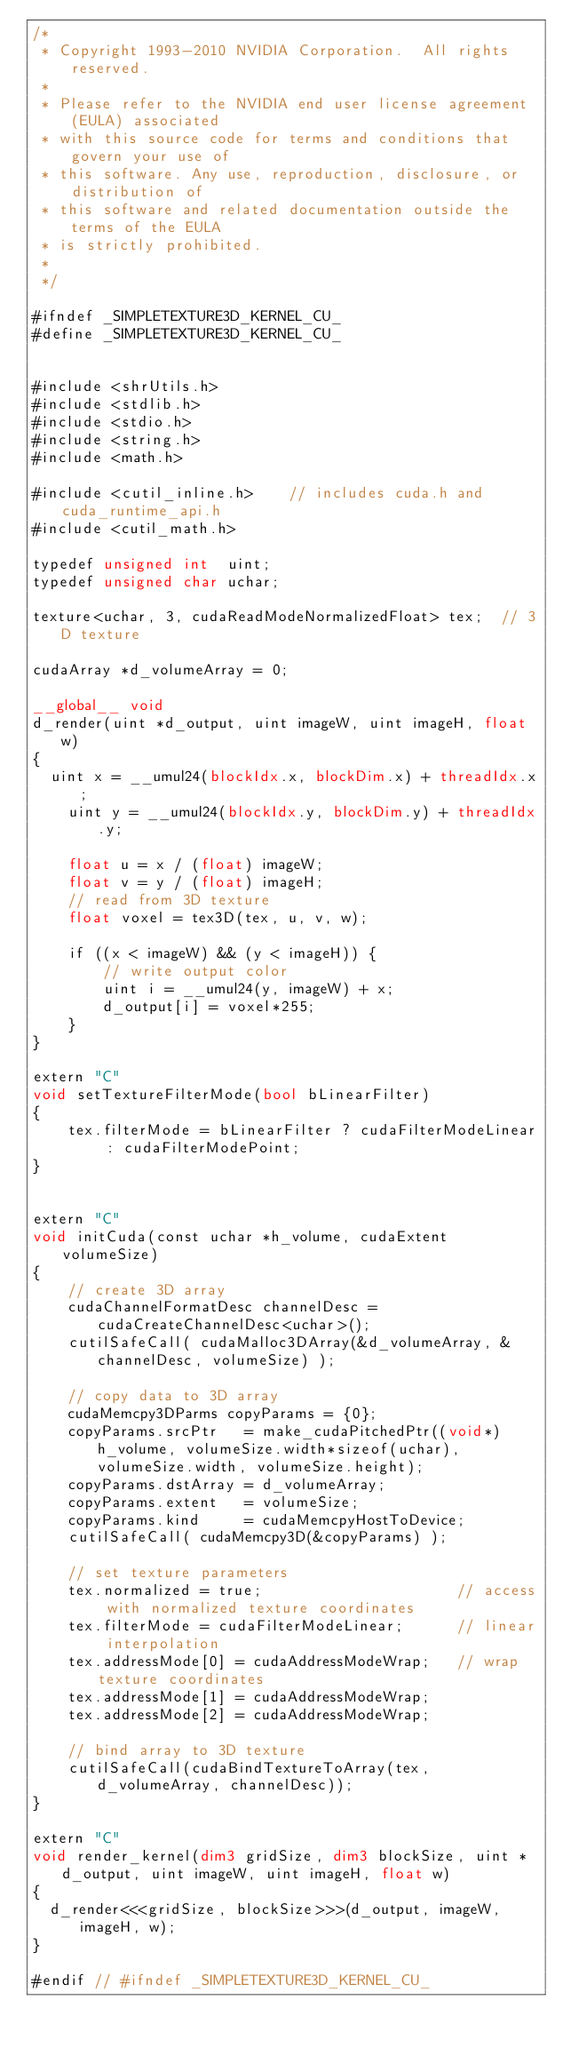Convert code to text. <code><loc_0><loc_0><loc_500><loc_500><_Cuda_>/*
 * Copyright 1993-2010 NVIDIA Corporation.  All rights reserved.
 *
 * Please refer to the NVIDIA end user license agreement (EULA) associated
 * with this source code for terms and conditions that govern your use of
 * this software. Any use, reproduction, disclosure, or distribution of
 * this software and related documentation outside the terms of the EULA
 * is strictly prohibited.
 *
 */

#ifndef _SIMPLETEXTURE3D_KERNEL_CU_
#define _SIMPLETEXTURE3D_KERNEL_CU_


#include <shrUtils.h>
#include <stdlib.h>
#include <stdio.h>
#include <string.h>
#include <math.h>

#include <cutil_inline.h>    // includes cuda.h and cuda_runtime_api.h
#include <cutil_math.h>

typedef unsigned int  uint;
typedef unsigned char uchar;

texture<uchar, 3, cudaReadModeNormalizedFloat> tex;  // 3D texture

cudaArray *d_volumeArray = 0;

__global__ void
d_render(uint *d_output, uint imageW, uint imageH, float w)
{
	uint x = __umul24(blockIdx.x, blockDim.x) + threadIdx.x;
    uint y = __umul24(blockIdx.y, blockDim.y) + threadIdx.y;

    float u = x / (float) imageW;
    float v = y / (float) imageH;
    // read from 3D texture
    float voxel = tex3D(tex, u, v, w);

    if ((x < imageW) && (y < imageH)) {
        // write output color
        uint i = __umul24(y, imageW) + x;
        d_output[i] = voxel*255;
    }
}

extern "C"
void setTextureFilterMode(bool bLinearFilter)
{
    tex.filterMode = bLinearFilter ? cudaFilterModeLinear : cudaFilterModePoint;
}


extern "C"
void initCuda(const uchar *h_volume, cudaExtent volumeSize)
{
    // create 3D array
    cudaChannelFormatDesc channelDesc = cudaCreateChannelDesc<uchar>();
    cutilSafeCall( cudaMalloc3DArray(&d_volumeArray, &channelDesc, volumeSize) );

    // copy data to 3D array
    cudaMemcpy3DParms copyParams = {0};
    copyParams.srcPtr   = make_cudaPitchedPtr((void*)h_volume, volumeSize.width*sizeof(uchar), volumeSize.width, volumeSize.height);
    copyParams.dstArray = d_volumeArray;
    copyParams.extent   = volumeSize;
    copyParams.kind     = cudaMemcpyHostToDevice;
    cutilSafeCall( cudaMemcpy3D(&copyParams) );

    // set texture parameters
    tex.normalized = true;                      // access with normalized texture coordinates
    tex.filterMode = cudaFilterModeLinear;      // linear interpolation
    tex.addressMode[0] = cudaAddressModeWrap;   // wrap texture coordinates
    tex.addressMode[1] = cudaAddressModeWrap;
    tex.addressMode[2] = cudaAddressModeWrap;

    // bind array to 3D texture
    cutilSafeCall(cudaBindTextureToArray(tex, d_volumeArray, channelDesc));
}

extern "C"
void render_kernel(dim3 gridSize, dim3 blockSize, uint *d_output, uint imageW, uint imageH, float w)
{
	d_render<<<gridSize, blockSize>>>(d_output, imageW, imageH, w);
}

#endif // #ifndef _SIMPLETEXTURE3D_KERNEL_CU_
</code> 